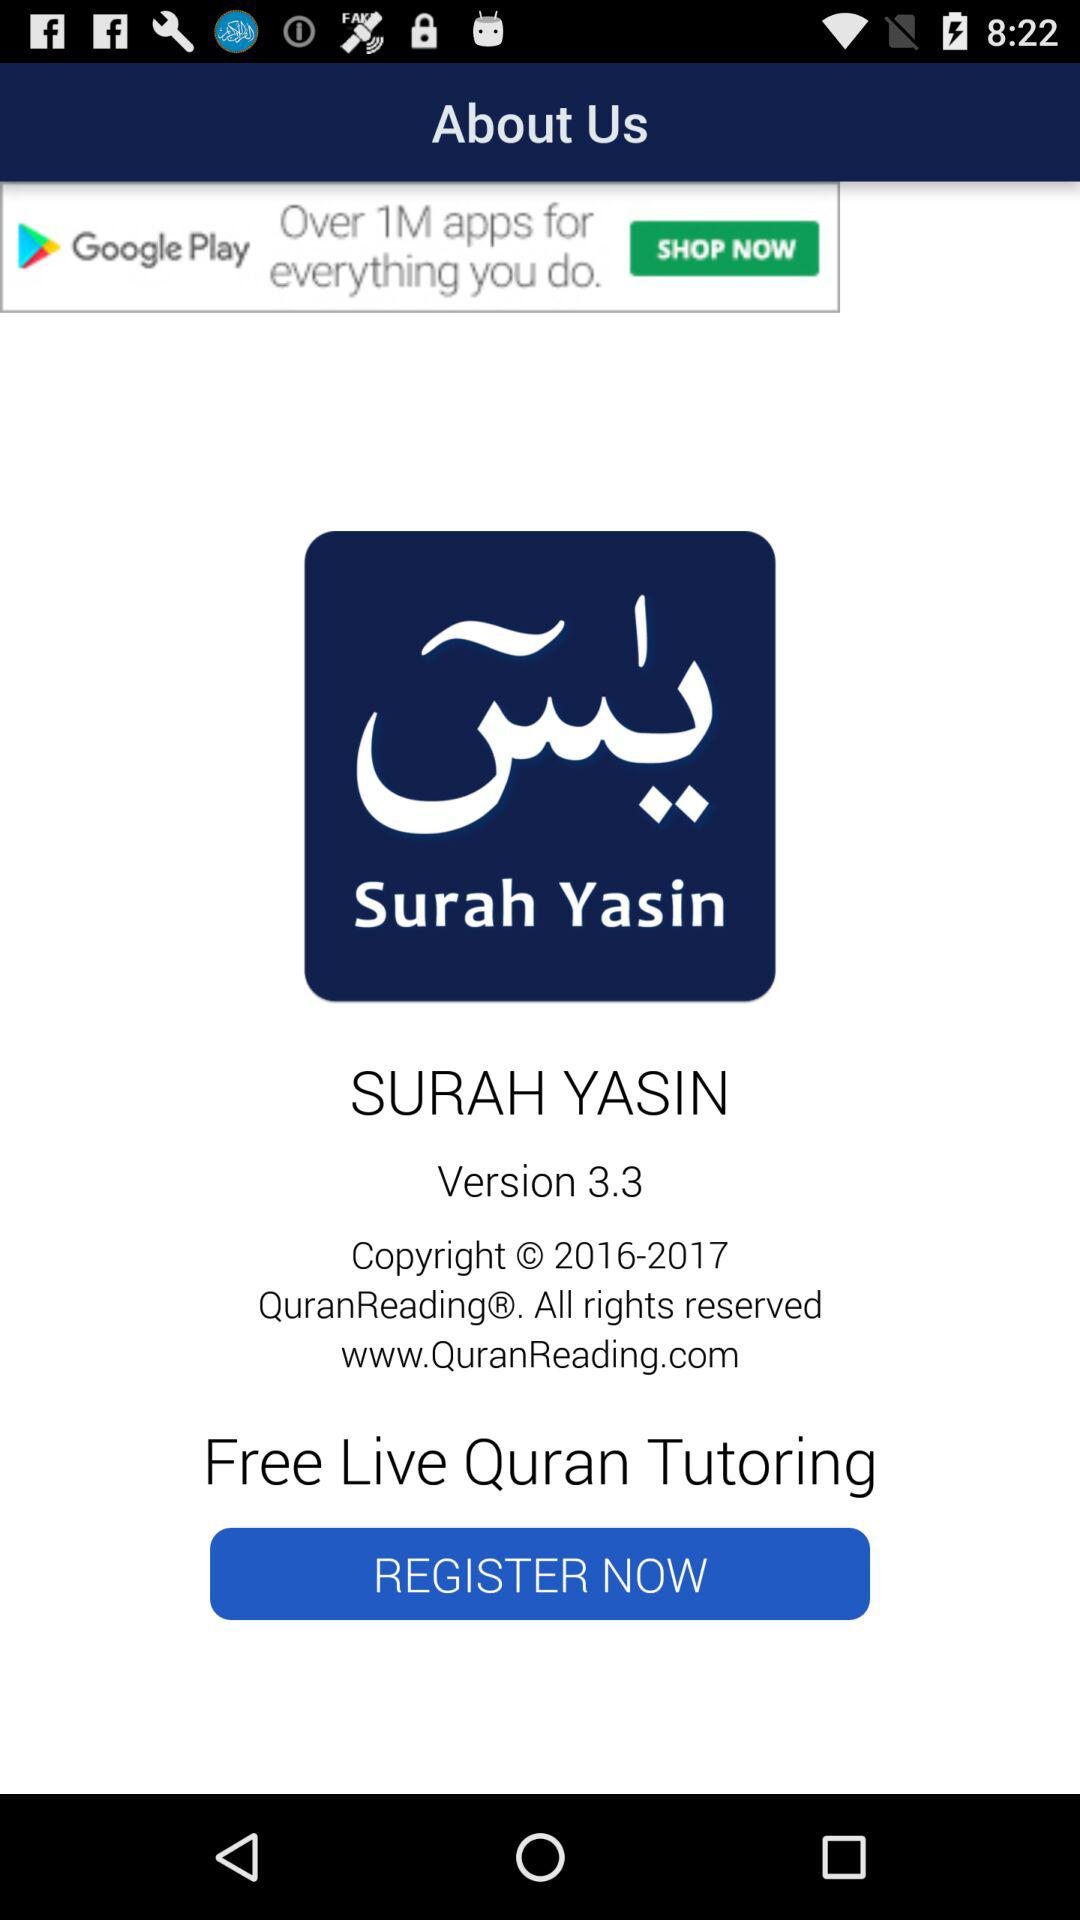Which version is used? The used version is 3.3. 